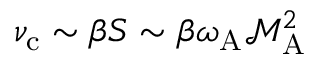Convert formula to latex. <formula><loc_0><loc_0><loc_500><loc_500>\nu _ { c } \sim \beta S \sim \beta \omega _ { A } \mathcal { M } _ { A } ^ { 2 }</formula> 